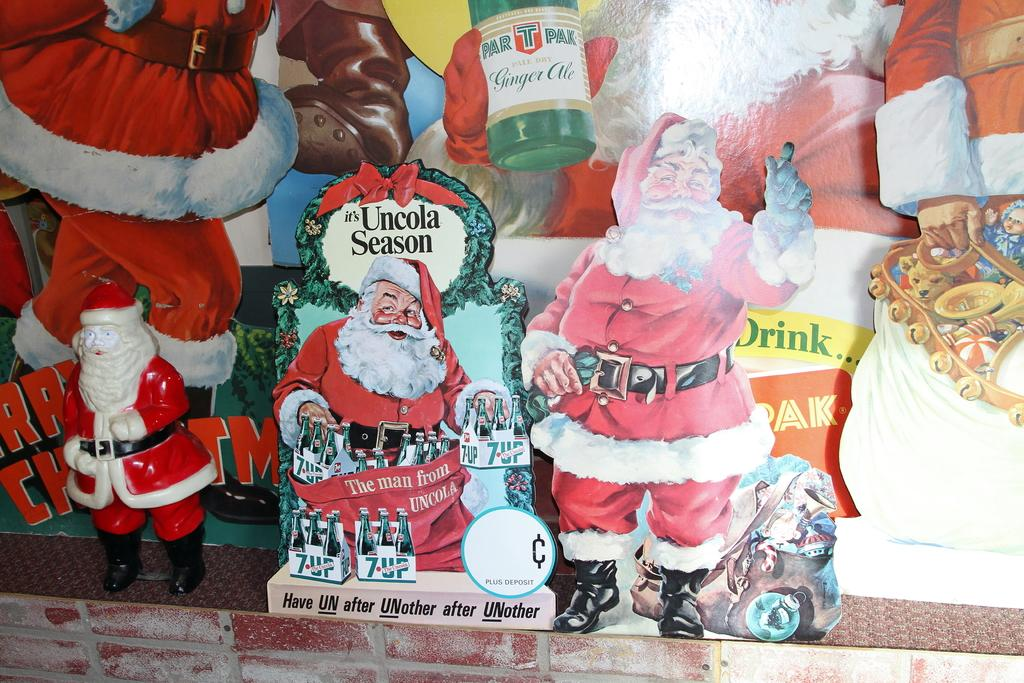What type of signage is present in the image? There are hoardings in the image. What is depicted on one of the hoardings? One of the hoardings features Santa Claus. What is shown on another hoarding? Another hoarding features a toy. Where are the hoardings located? The hoardings are on a platform. What is the smell of the toy on the hoarding in the image? There is no information about the smell of the toy or any other aspect of the image that involves smell, as the image is visual. 